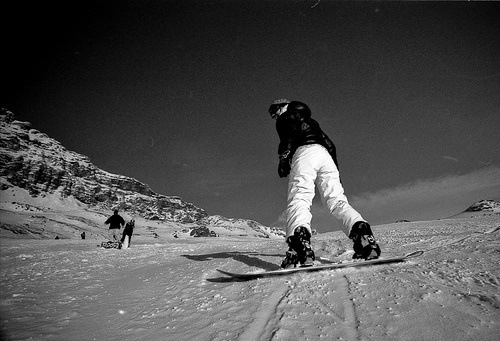Describe the objects in this image and their specific colors. I can see people in black, white, gray, and darkgray tones, snowboard in black, gray, darkgray, and lightgray tones, people in black, gray, and lightgray tones, and people in black and gray tones in this image. 